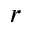<formula> <loc_0><loc_0><loc_500><loc_500>r</formula> 